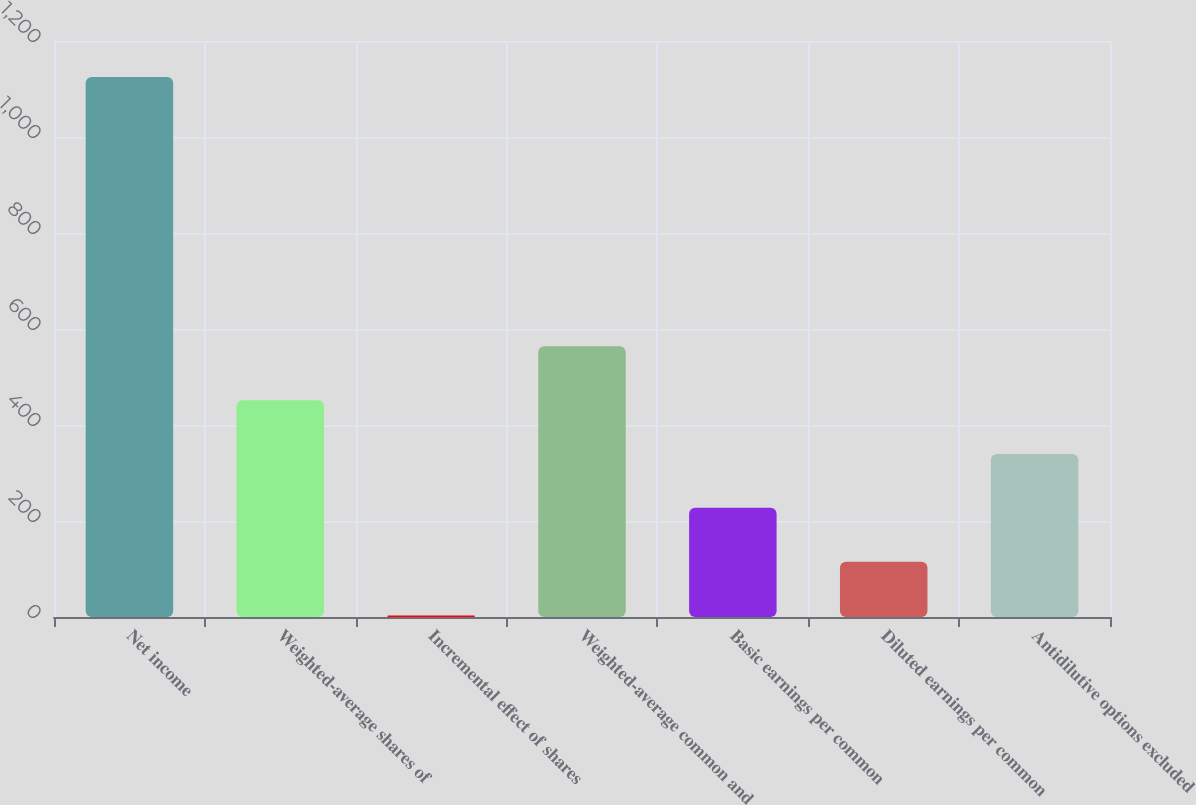Convert chart. <chart><loc_0><loc_0><loc_500><loc_500><bar_chart><fcel>Net income<fcel>Weighted-average shares of<fcel>Incremental effect of shares<fcel>Weighted-average common and<fcel>Basic earnings per common<fcel>Diluted earnings per common<fcel>Antidilutive options excluded<nl><fcel>1125<fcel>451.8<fcel>3<fcel>564<fcel>227.4<fcel>115.2<fcel>339.6<nl></chart> 